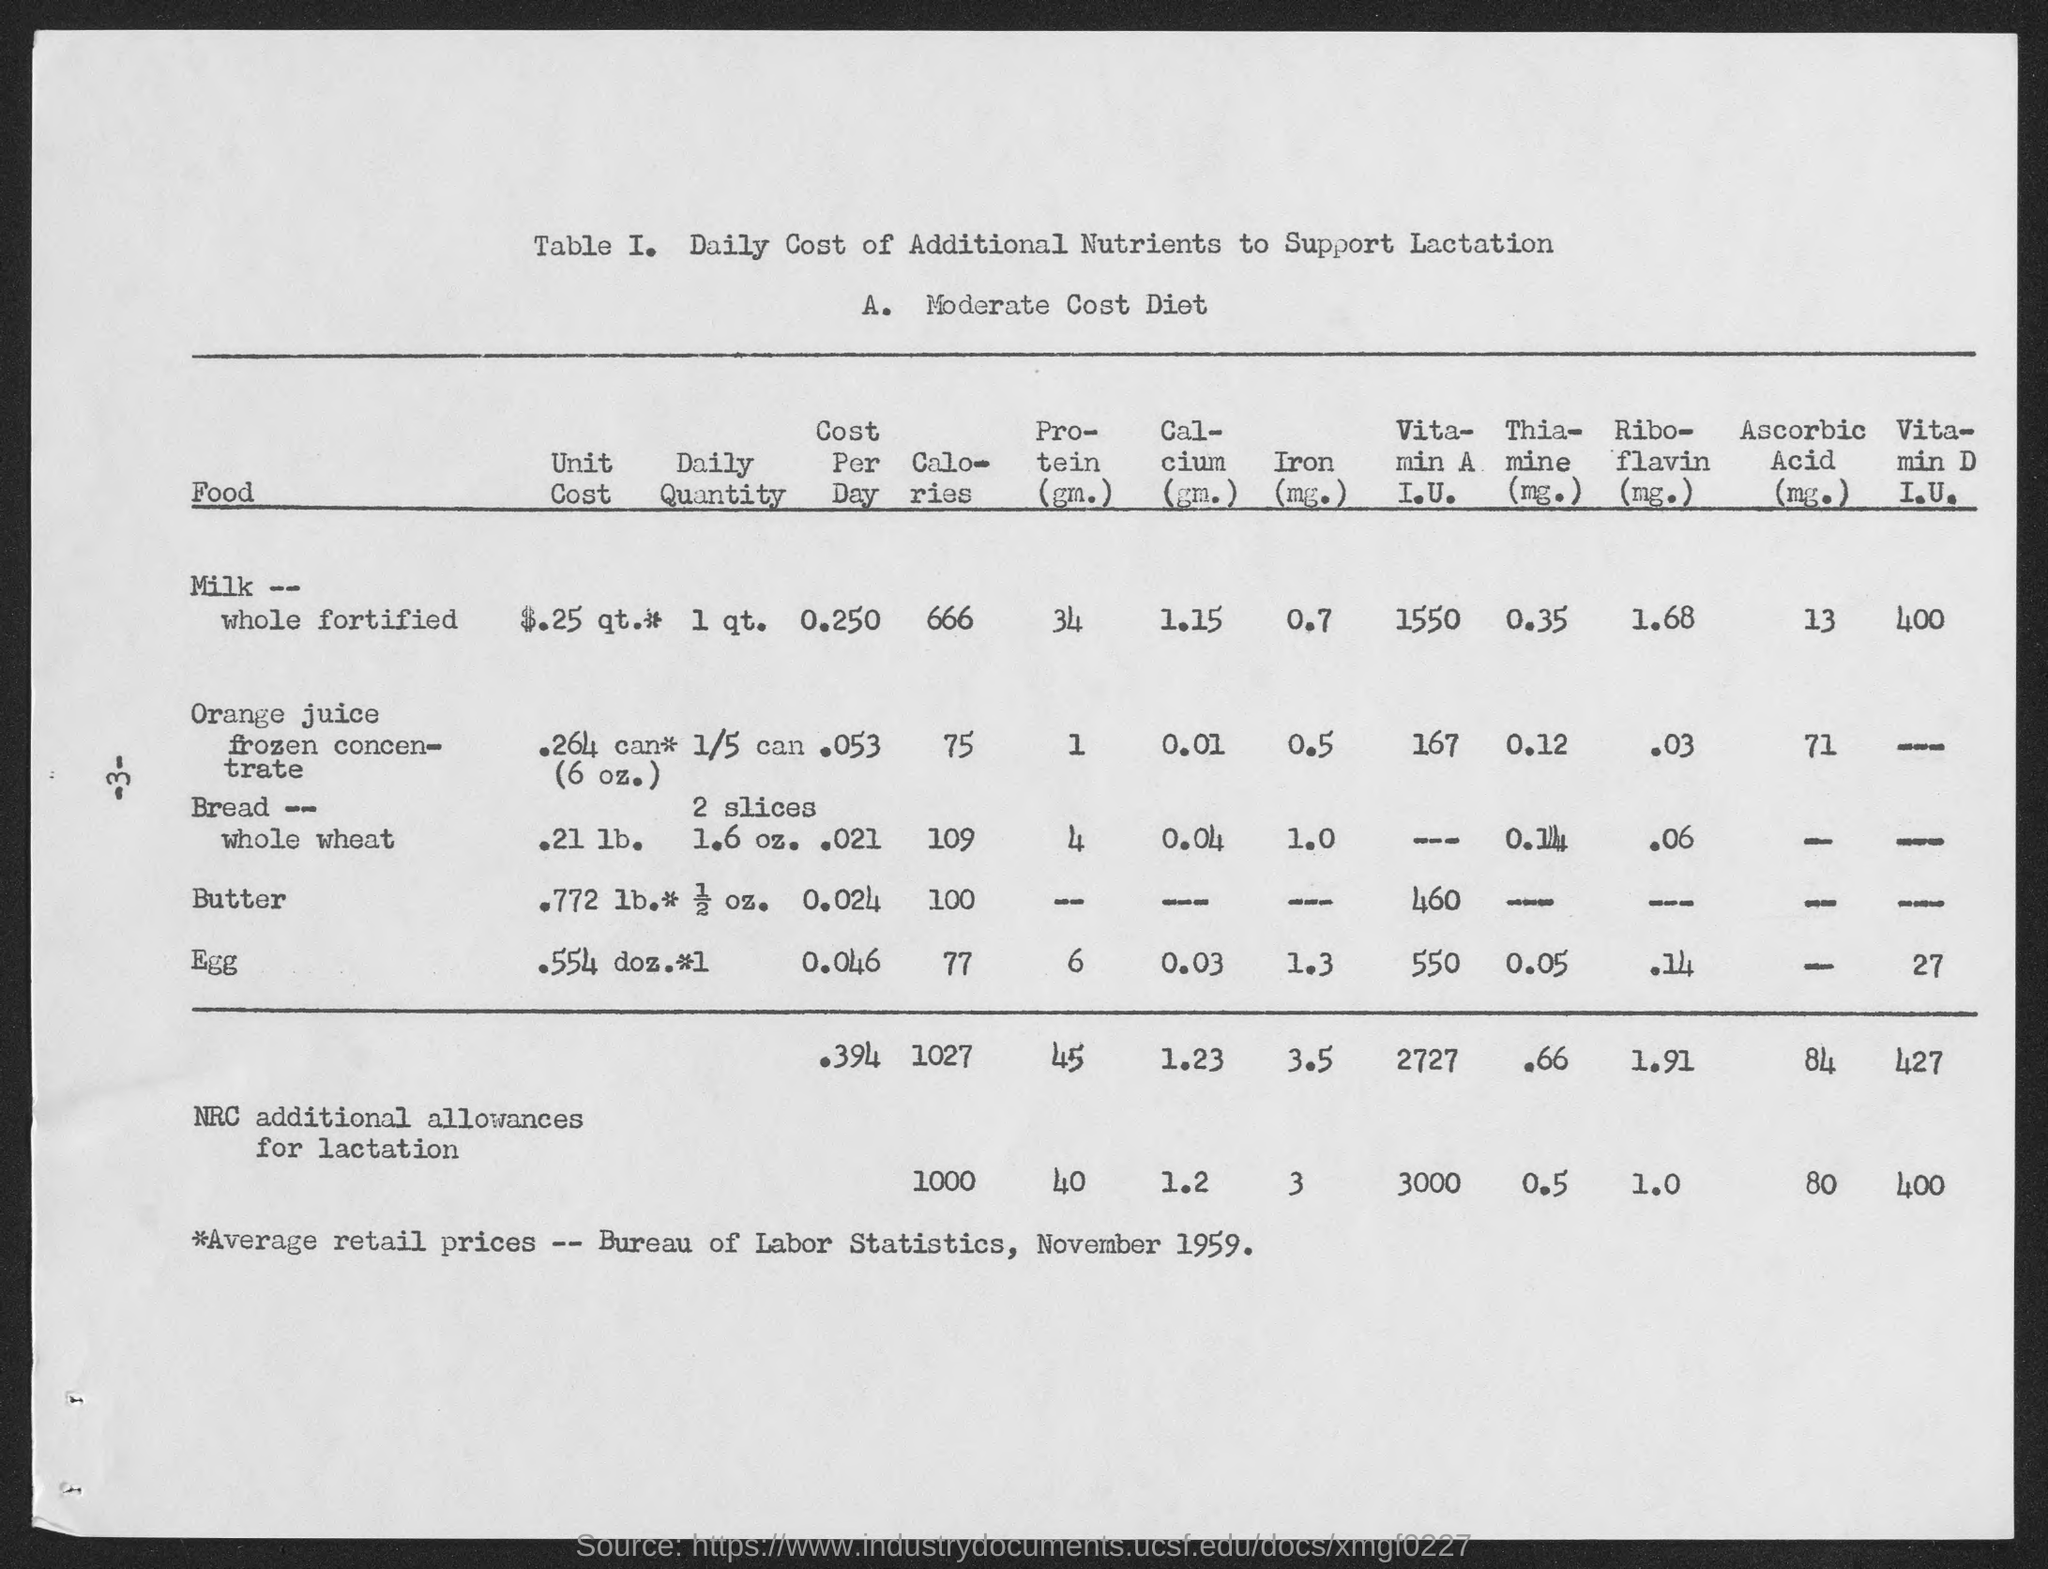What are the calories for Milk-whole fortified?
Provide a succinct answer. 666. What are the calories for Orange juice frozen concentrate?
Your response must be concise. 75. What are the calories for Bread- whole wheat?
Your answer should be compact. 109. What are the calories for Butter?
Provide a short and direct response. 100. What are the calories for Egg?
Your answer should be compact. 77. What are the Protein(gm.) for Milk-whole fortified?
Your response must be concise. 34. What are the Protein(gm.) for Orange juice frozen concentrate?
Provide a succinct answer. 1. What are the Protein(gm.) for Bread- whole wheat?
Your answer should be very brief. 4. What are the Protein(gm.) for egg?
Your answer should be very brief. 6. What are the Calcium (gm.) for egg?
Your response must be concise. 0.03. 